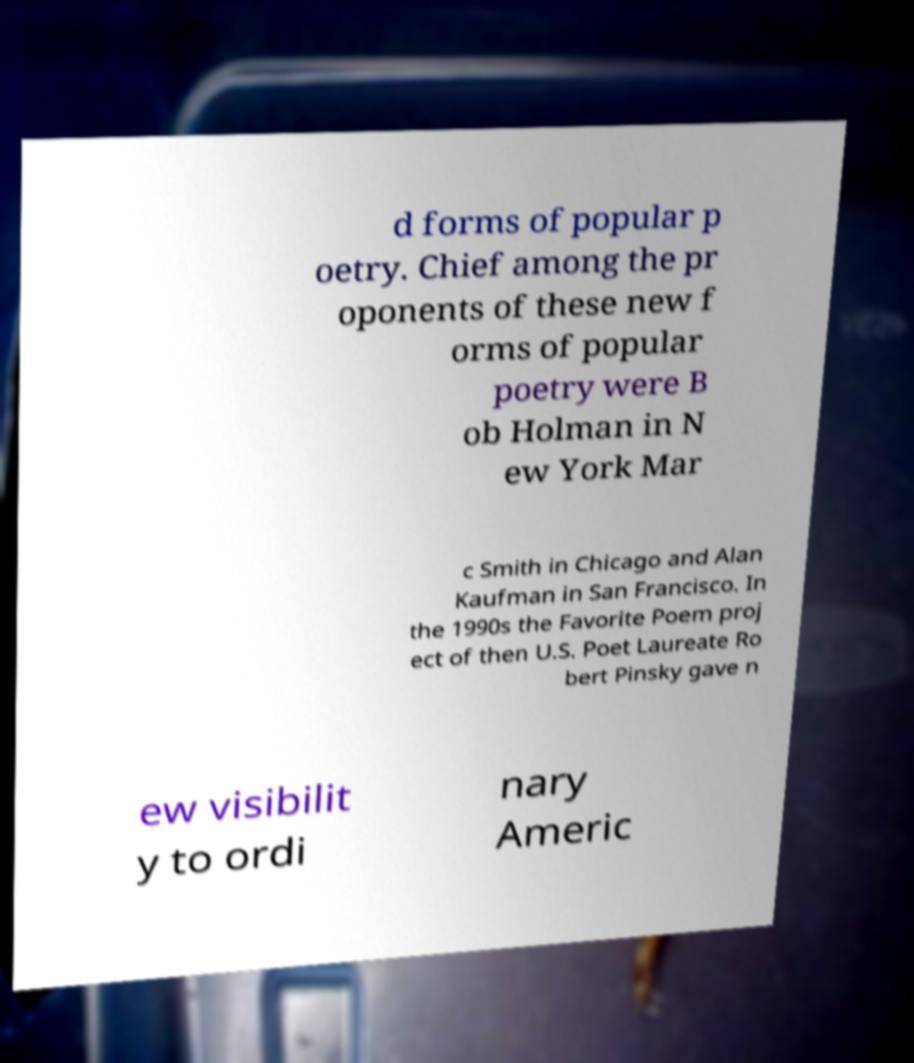What messages or text are displayed in this image? I need them in a readable, typed format. d forms of popular p oetry. Chief among the pr oponents of these new f orms of popular poetry were B ob Holman in N ew York Mar c Smith in Chicago and Alan Kaufman in San Francisco. In the 1990s the Favorite Poem proj ect of then U.S. Poet Laureate Ro bert Pinsky gave n ew visibilit y to ordi nary Americ 